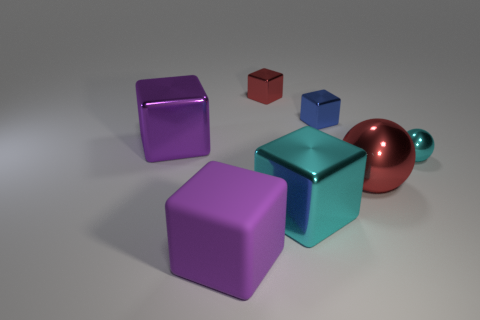Can you describe the arrangement and different sizes of objects? The objects are arranged with ample space between them, seemingly placed without a specific pattern. Their sizes vary: there are larger objects at the front, such as the purple and cyan cubes, and smaller ones in the back, like the red and blue cubes. Additionally, there's a sphere with a copper tone that contrasts with the geometric shapes of the cubes.  Does anything in the image imply motion or stillness? All objects are resting on a flat surface, suggesting complete stillness. There are no indications of recent movement or interactive dynamics among the objects. 